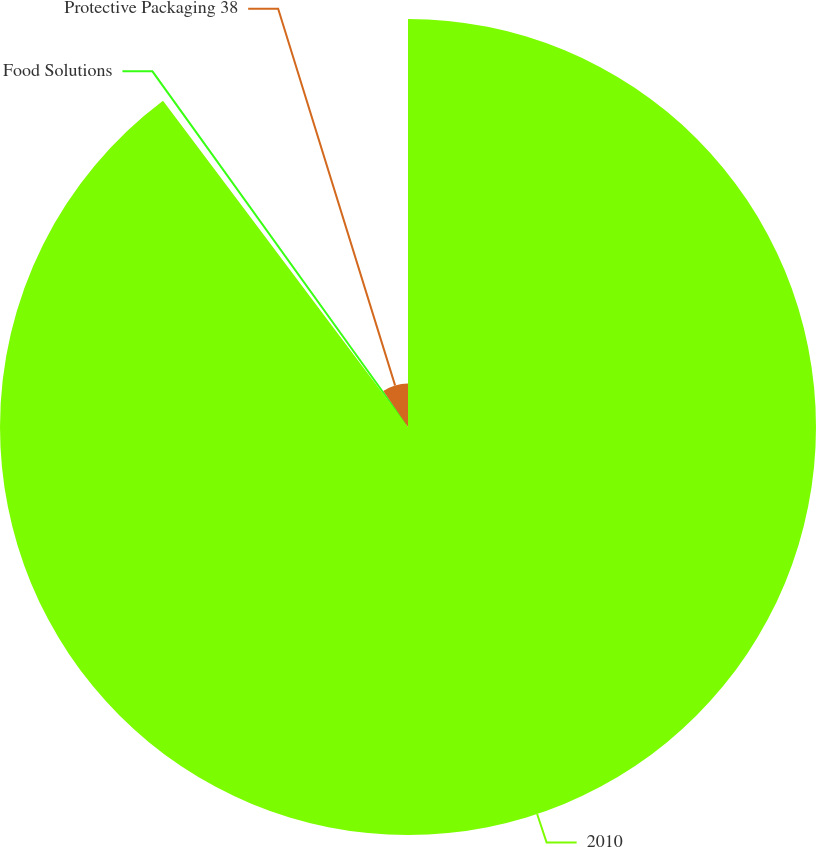<chart> <loc_0><loc_0><loc_500><loc_500><pie_chart><fcel>2010<fcel>Food Solutions<fcel>Protective Packaging 38<nl><fcel>89.74%<fcel>0.67%<fcel>9.58%<nl></chart> 